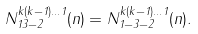<formula> <loc_0><loc_0><loc_500><loc_500>N ^ { k ( k - 1 ) \dots 1 } _ { 1 3 - 2 } ( n ) = N ^ { k ( k - 1 ) \dots 1 } _ { 1 - 3 - 2 } ( n ) .</formula> 